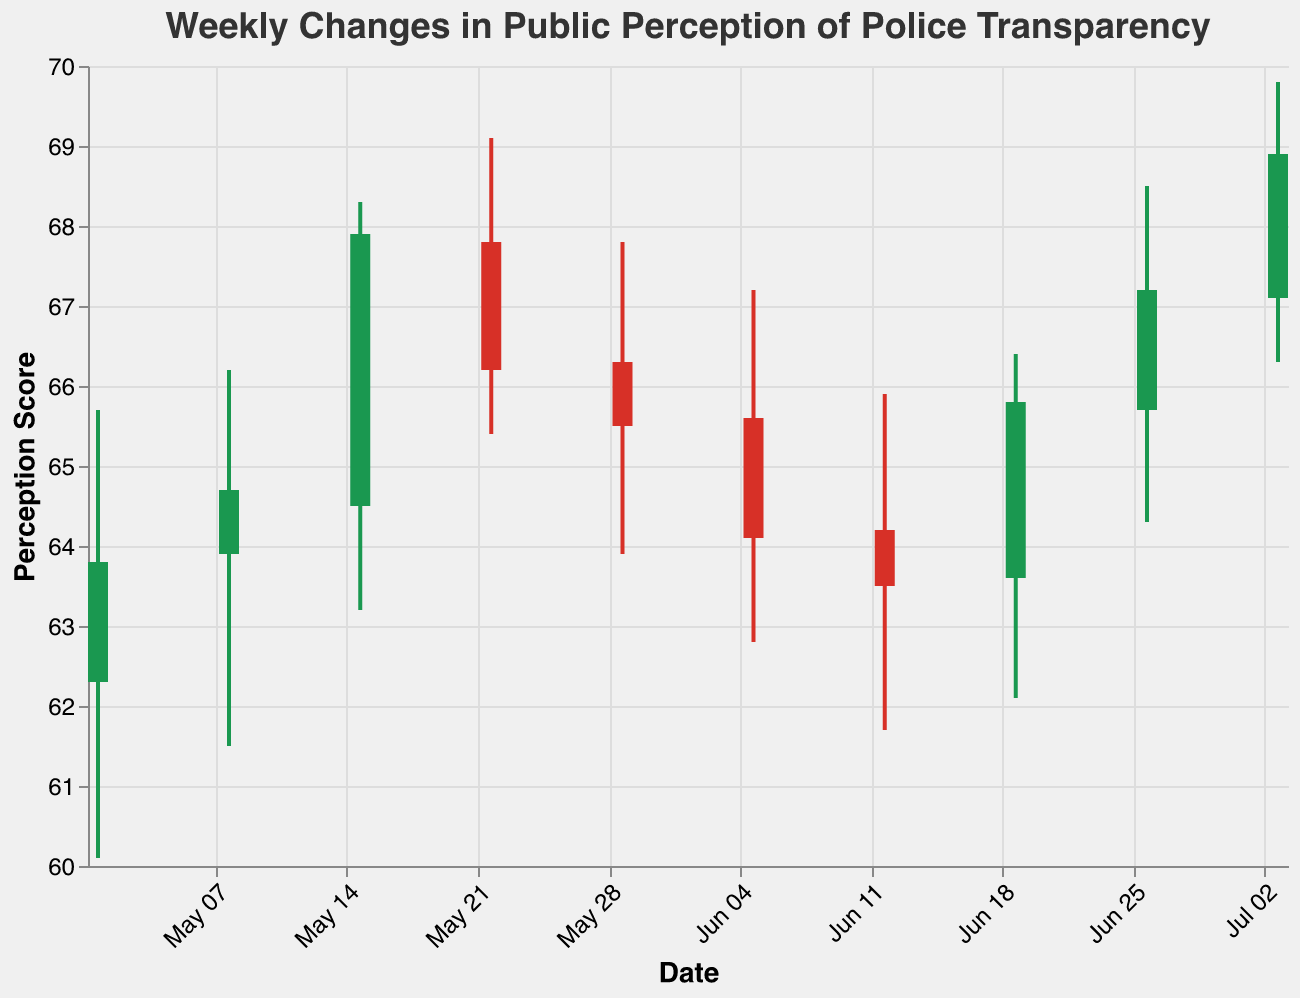What is the highest value seen during the week of May 15, 2023? The highest value is indicated by the "High" field for the week of May 15, 2023, which is 68.3.
Answer: 68.3 What is the general trend in public perception from May 1, 2023, to July 3, 2023, based on the closing values? By examining the closing values: 63.8, 64.7, 67.9, 66.2, 65.5, 64.1, 63.5, 65.8, 67.2, and 68.9, there appears to be an overall increase in the public perception score over time.
Answer: Increasing Which weeks had a closing value lower than the opening value? The weeks with closing values lower than the opening values are weeks starting on May 22, 2023, May 29, 2023, June 5, 2023, and June 12, 2023.
Answer: May 22, May 29, June 5, June 12 What is the average closing value for the month of June 2023? The closing values for June 2023 are 64.1, 63.5, 65.8, and 67.2. The average is calculated as (64.1 + 63.5 + 65.8 + 67.2) / 4 = 65.15.
Answer: 65.15 Which week had the largest difference between the high and low values? The differences between the high and low values for each week are calculated, and the week with the largest difference is May 15, 2023, with a difference of 68.3 - 63.2 = 5.1.
Answer: May 15 What is the closing value on July 3, 2023? The closing value for the week of July 3, 2023, is given by the "Close" field, which is 68.9.
Answer: 68.9 Which week experienced the lowest low value? The lowest low value can be seen during the week of May 1, 2023, where the "Low" value is 60.1.
Answer: May 1 By how much did the perception score increase from May 8, 2023, to May 15, 2023, based on the closing values? The closing value on May 8, 2023, is 64.7 and on May 15, 2023, it is 67.9. The increase is calculated as 67.9 - 64.7 = 3.2.
Answer: 3.2 What is the opening value for the week starting on June 26, 2023? The opening value for the week of June 26, 2023, is specified by the "Open" field, which is 65.7.
Answer: 65.7 Which week had the highest closing value, and what was that value? The highest closing value is observed in the week of July 3, 2023, with a closing value of 68.9.
Answer: July 3, 68.9 